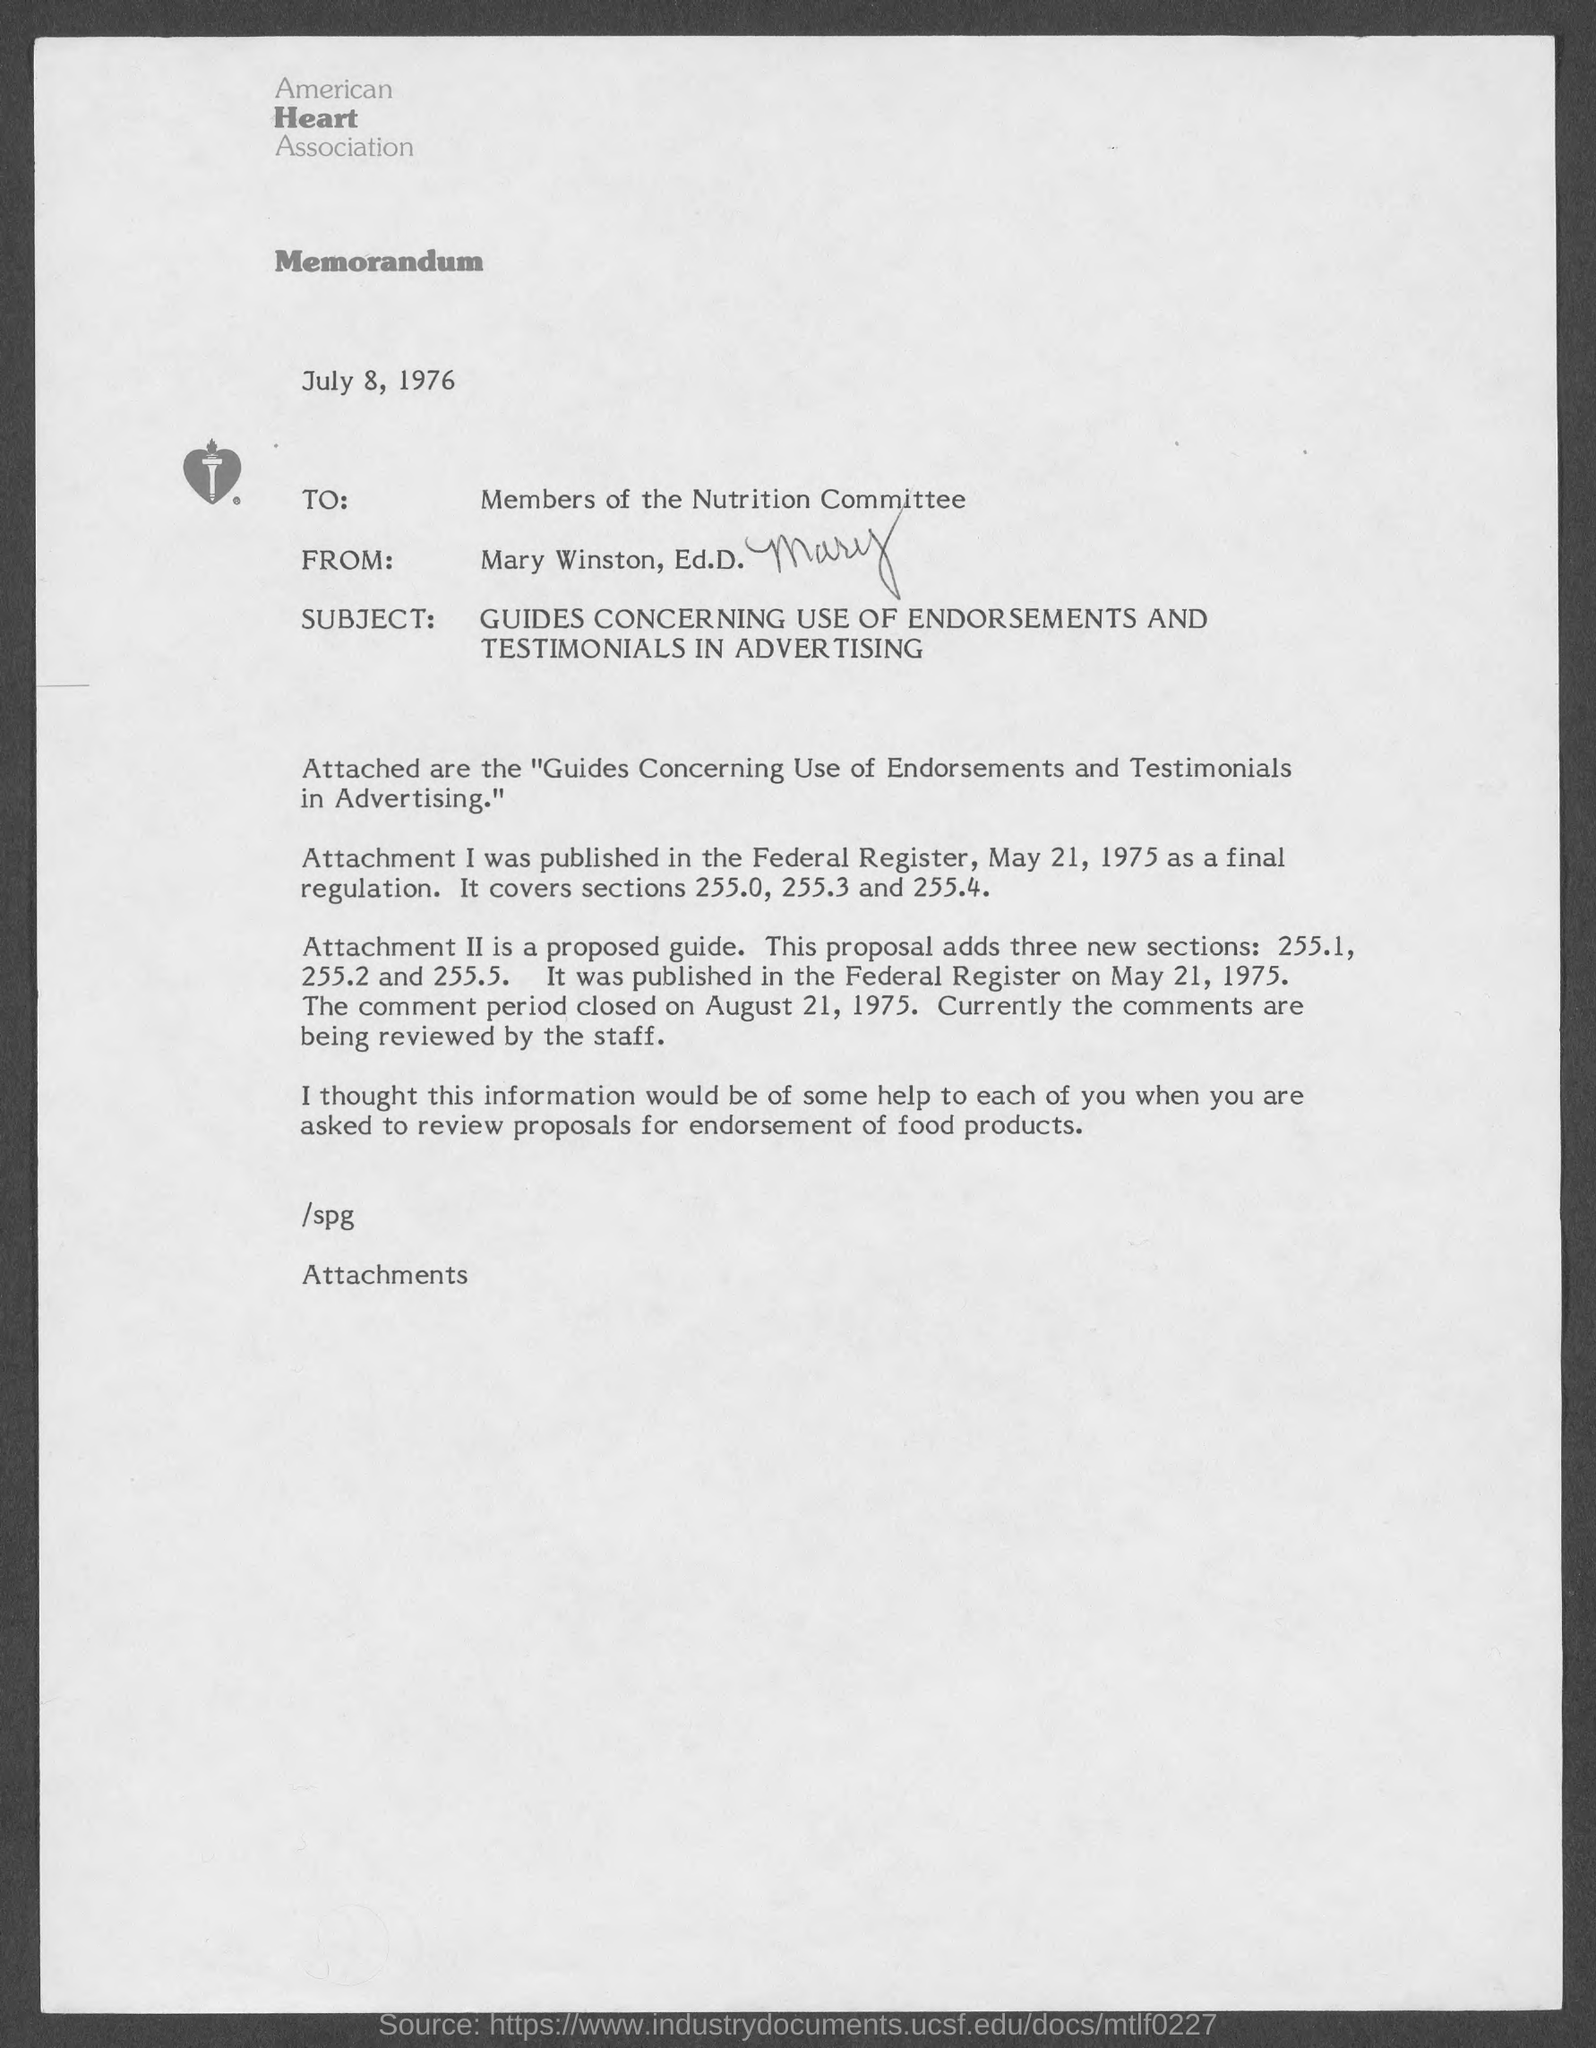What is the date on the document?
Provide a succinct answer. July 8, 1976. To Whom is this letter addressed to?
Ensure brevity in your answer.  Members of the Nutrition Committee. Who is this letter from?
Your answer should be very brief. Mary Winston, Ed.D. Where was attachment 1 published?
Ensure brevity in your answer.  Federal Register. 